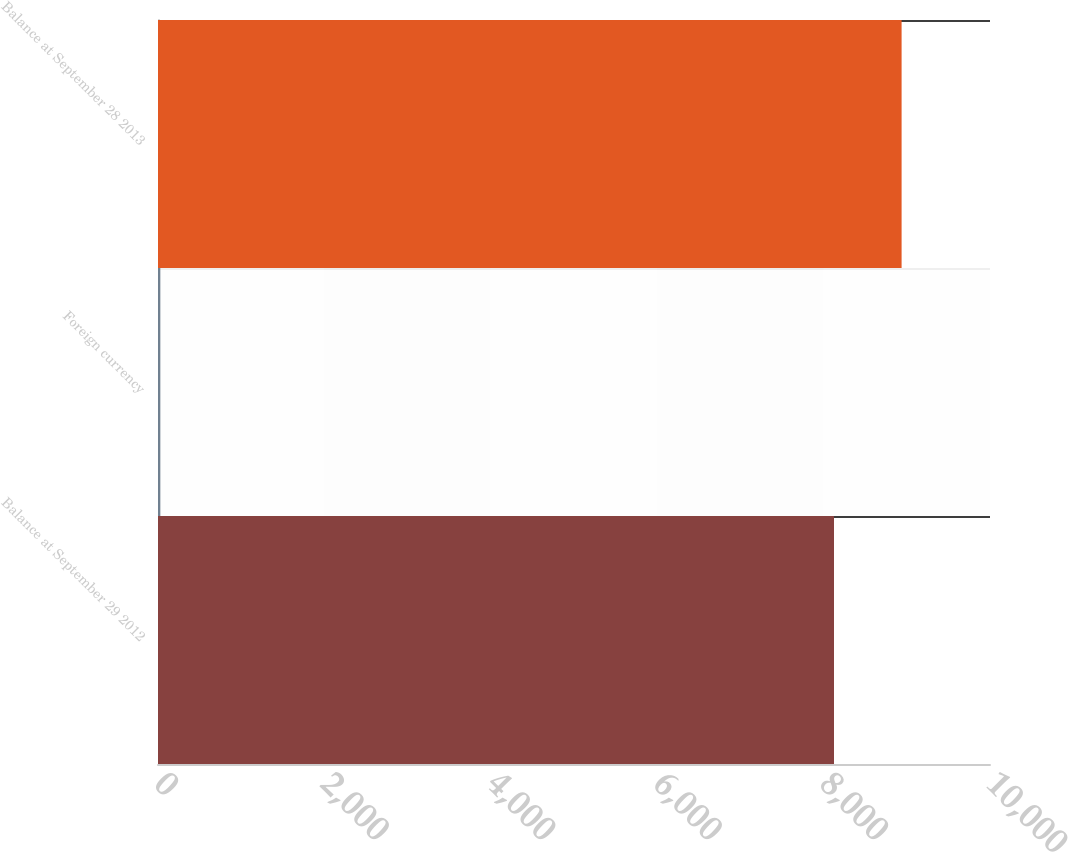Convert chart. <chart><loc_0><loc_0><loc_500><loc_500><bar_chart><fcel>Balance at September 29 2012<fcel>Foreign currency<fcel>Balance at September 28 2013<nl><fcel>8125<fcel>28<fcel>8937.5<nl></chart> 